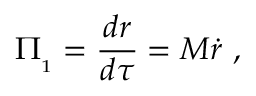<formula> <loc_0><loc_0><loc_500><loc_500>{ \mathit \Pi } _ { _ { 1 } } = { \frac { d r } { d \tau } } = M \dot { r } \ ,</formula> 